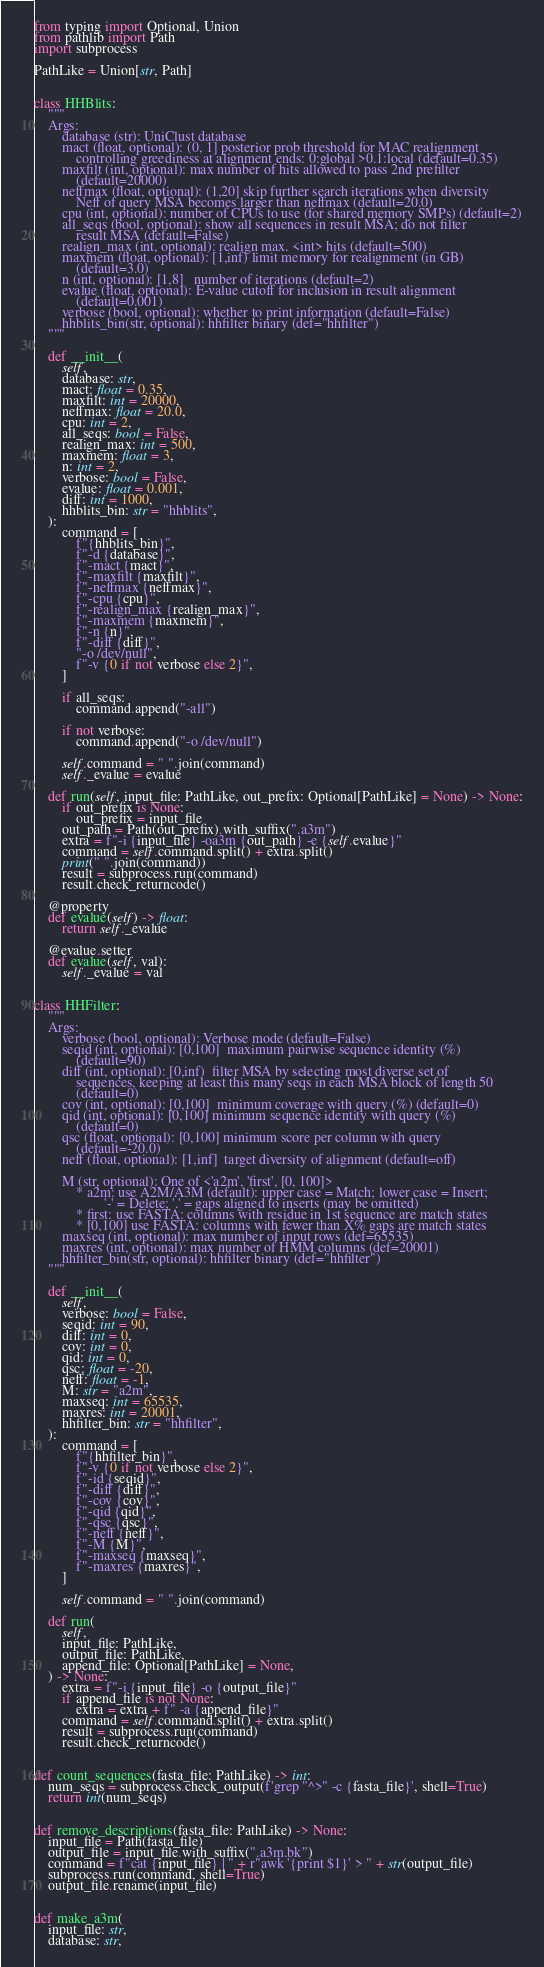<code> <loc_0><loc_0><loc_500><loc_500><_Python_>from typing import Optional, Union
from pathlib import Path
import subprocess

PathLike = Union[str, Path]


class HHBlits:
    """
    Args:
        database (str): UniClust database
        mact (float, optional): (0, 1] posterior prob threshold for MAC realignment
            controlling greediness at alignment ends: 0:global >0.1:local (default=0.35)
        maxfilt (int, optional): max number of hits allowed to pass 2nd prefilter
            (default=20000)
        neffmax (float, optional): (1,20] skip further search iterations when diversity
            Neff of query MSA becomes larger than neffmax (default=20.0)
        cpu (int, optional): number of CPUs to use (for shared memory SMPs) (default=2)
        all_seqs (bool, optional): show all sequences in result MSA; do not filter
            result MSA (default=False)
        realign_max (int, optional): realign max. <int> hits (default=500)
        maxmem (float, optional): [1,inf) limit memory for realignment (in GB)
            (default=3.0)
        n (int, optional): [1,8]   number of iterations (default=2)
        evalue (float, optional): E-value cutoff for inclusion in result alignment
            (default=0.001)
        verbose (bool, optional): whether to print information (default=False)
        hhblits_bin(str, optional): hhfilter binary (def="hhfilter")
    """

    def __init__(
        self,
        database: str,
        mact: float = 0.35,
        maxfilt: int = 20000,
        neffmax: float = 20.0,
        cpu: int = 2,
        all_seqs: bool = False,
        realign_max: int = 500,
        maxmem: float = 3,
        n: int = 2,
        verbose: bool = False,
        evalue: float = 0.001,
        diff: int = 1000,
        hhblits_bin: str = "hhblits",
    ):
        command = [
            f"{hhblits_bin}",
            f"-d {database}",
            f"-mact {mact}",
            f"-maxfilt {maxfilt}",
            f"-neffmax {neffmax}",
            f"-cpu {cpu}",
            f"-realign_max {realign_max}",
            f"-maxmem {maxmem}",
            f"-n {n}",
            f"-diff {diff}",
            "-o /dev/null",
            f"-v {0 if not verbose else 2}",
        ]

        if all_seqs:
            command.append("-all")

        if not verbose:
            command.append("-o /dev/null")

        self.command = " ".join(command)
        self._evalue = evalue

    def run(self, input_file: PathLike, out_prefix: Optional[PathLike] = None) -> None:
        if out_prefix is None:
            out_prefix = input_file
        out_path = Path(out_prefix).with_suffix(".a3m")
        extra = f"-i {input_file} -oa3m {out_path} -e {self.evalue}"
        command = self.command.split() + extra.split()
        print(" ".join(command))
        result = subprocess.run(command)
        result.check_returncode()

    @property
    def evalue(self) -> float:
        return self._evalue

    @evalue.setter
    def evalue(self, val):
        self._evalue = val


class HHFilter:
    """
    Args:
        verbose (bool, optional): Verbose mode (default=False)
        seqid (int, optional): [0,100]  maximum pairwise sequence identity (%)
            (default=90)
        diff (int, optional): [0,inf)  filter MSA by selecting most diverse set of
            sequences, keeping at least this many seqs in each MSA block of length 50
            (default=0)
        cov (int, optional): [0,100]  minimum coverage with query (%) (default=0)
        qid (int, optional): [0,100] minimum sequence identity with query (%)
            (default=0)
        qsc (float, optional): [0,100] minimum score per column with query
            (default=-20.0)
        neff (float, optional): [1,inf]  target diversity of alignment (default=off)

        M (str, optional): One of <'a2m', 'first', [0, 100]>
            * a2m: use A2M/A3M (default): upper case = Match; lower case = Insert;
                    '-' = Delete; '.' = gaps aligned to inserts (may be omitted)
            * first: use FASTA: columns with residue in 1st sequence are match states
            * [0,100] use FASTA: columns with fewer than X% gaps are match states
        maxseq (int, optional): max number of input rows (def=65535)
        maxres (int, optional): max number of HMM columns (def=20001)
        hhfilter_bin(str, optional): hhfilter binary (def="hhfilter")
    """

    def __init__(
        self,
        verbose: bool = False,
        seqid: int = 90,
        diff: int = 0,
        cov: int = 0,
        qid: int = 0,
        qsc: float = -20,
        neff: float = -1,
        M: str = "a2m",
        maxseq: int = 65535,
        maxres: int = 20001,
        hhfilter_bin: str = "hhfilter",
    ):
        command = [
            f"{hhfilter_bin}",
            f"-v {0 if not verbose else 2}",
            f"-id {seqid}",
            f"-diff {diff}",
            f"-cov {cov}",
            f"-qid {qid}",
            f"-qsc {qsc}",
            f"-neff {neff}",
            f"-M {M}",
            f"-maxseq {maxseq}",
            f"-maxres {maxres}",
        ]

        self.command = " ".join(command)

    def run(
        self,
        input_file: PathLike,
        output_file: PathLike,
        append_file: Optional[PathLike] = None,
    ) -> None:
        extra = f"-i {input_file} -o {output_file}"
        if append_file is not None:
            extra = extra + f" -a {append_file}"
        command = self.command.split() + extra.split()
        result = subprocess.run(command)
        result.check_returncode()


def count_sequences(fasta_file: PathLike) -> int:
    num_seqs = subprocess.check_output(f'grep "^>" -c {fasta_file}', shell=True)
    return int(num_seqs)


def remove_descriptions(fasta_file: PathLike) -> None:
    input_file = Path(fasta_file)
    output_file = input_file.with_suffix(".a3m.bk")
    command = f"cat {input_file} | " + r"awk '{print $1}' > " + str(output_file)
    subprocess.run(command, shell=True)
    output_file.rename(input_file)


def make_a3m(
    input_file: str,
    database: str,</code> 